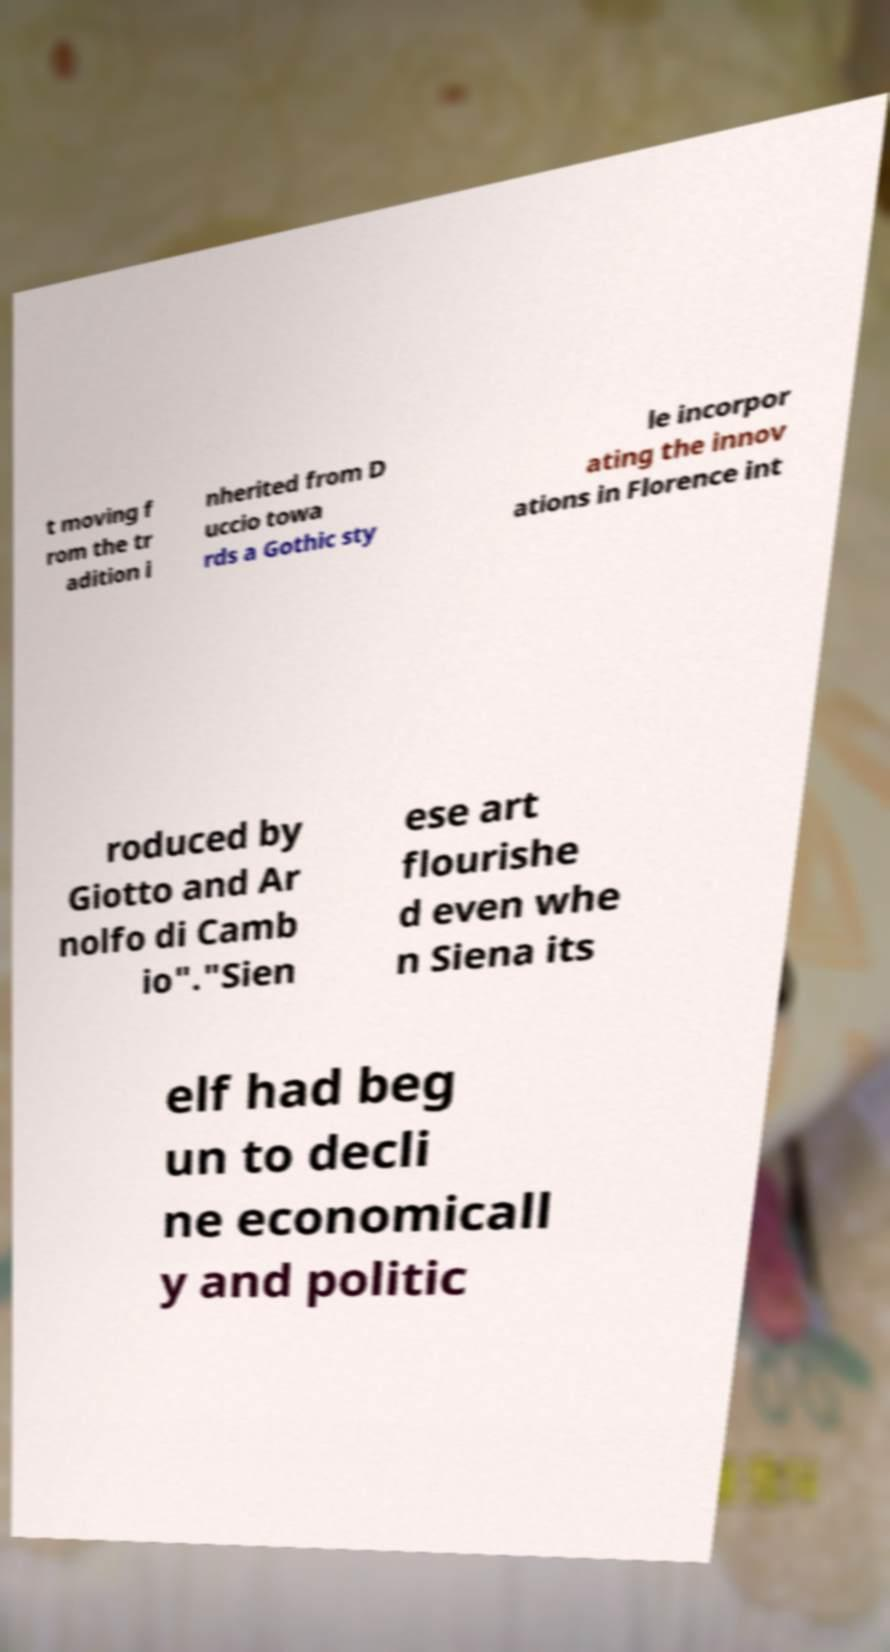I need the written content from this picture converted into text. Can you do that? t moving f rom the tr adition i nherited from D uccio towa rds a Gothic sty le incorpor ating the innov ations in Florence int roduced by Giotto and Ar nolfo di Camb io"."Sien ese art flourishe d even whe n Siena its elf had beg un to decli ne economicall y and politic 